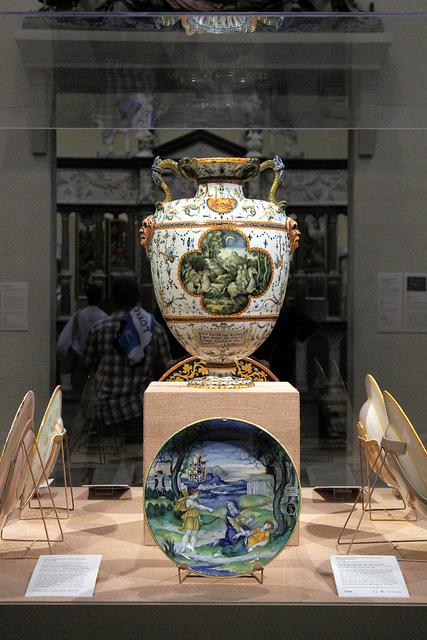Are these plates decorative or for use?
Concise answer only. Decorative. Are these items in a department store?
Quick response, please. No. How many plates?
Answer briefly. 5. 